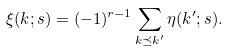<formula> <loc_0><loc_0><loc_500><loc_500>\xi ( { k } ; s ) = ( - 1 ) ^ { r - 1 } \sum _ { { k } \preceq { k ^ { \prime } } } \eta ( { k ^ { \prime } } ; s ) .</formula> 